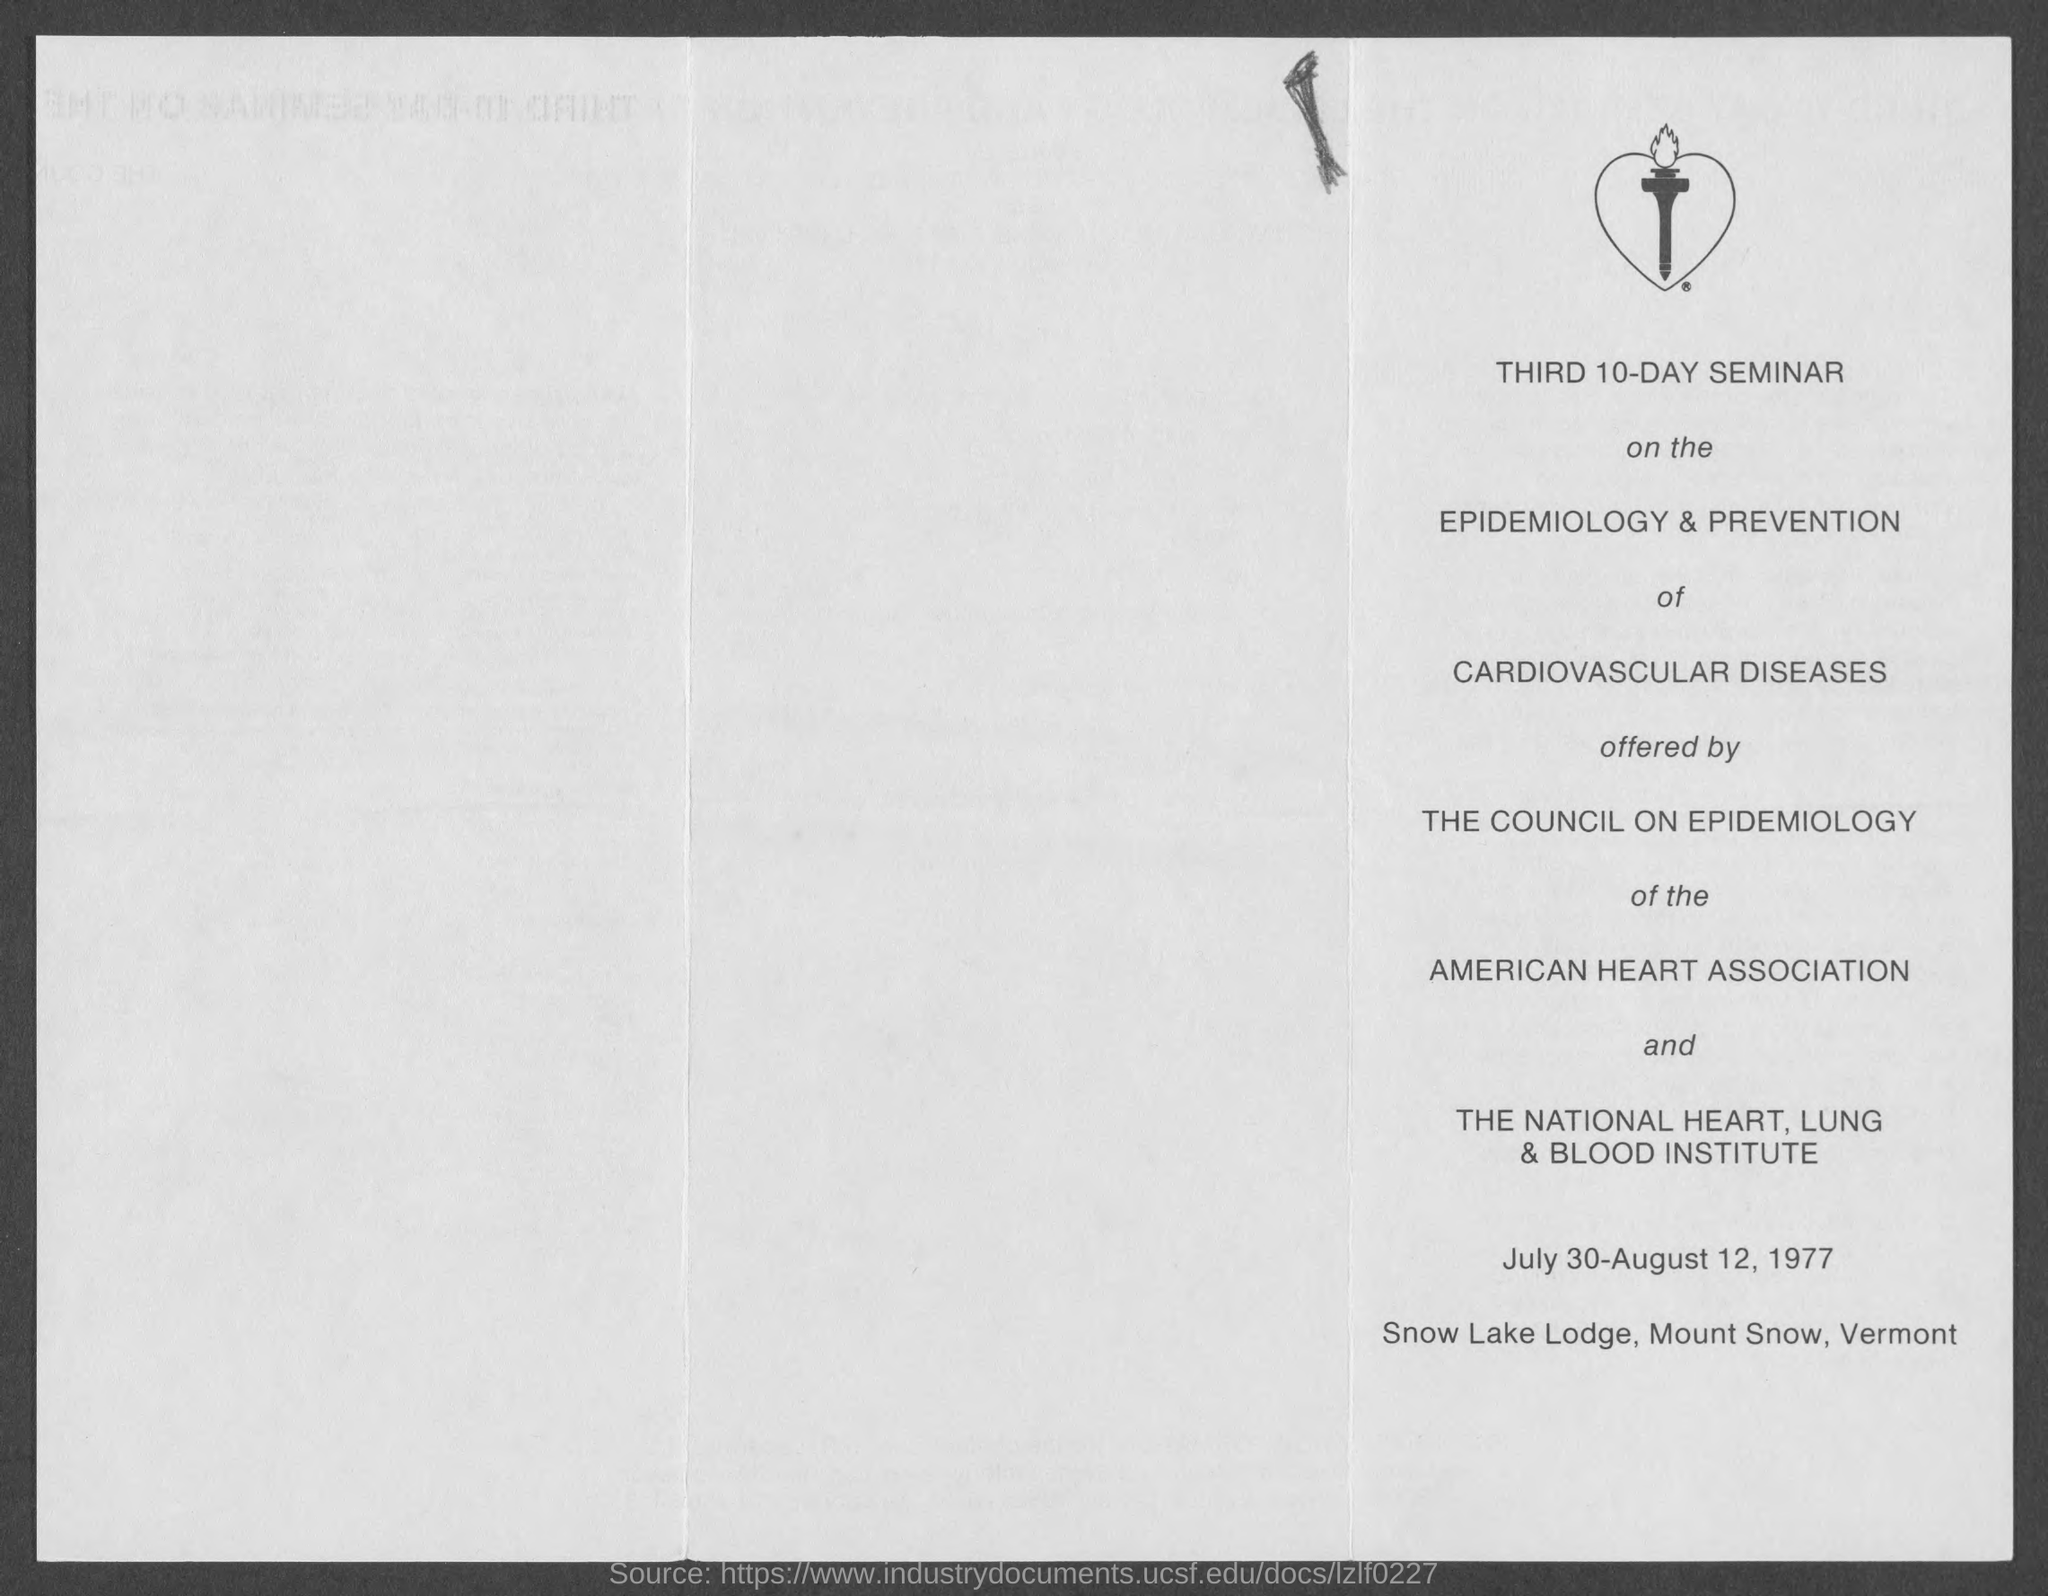Identify some key points in this picture. Cardiovascular diseases are the type of illness that was the focus of the seminar. The seminar will take place at Snow Lake Lodge, located in Mount Snow, Vermont. The Council on Epidemiology offered the seminar. The National Heart, Lung & Blood Institute has the power over The Council on Epidemiology. The American Heart Association has the power over The Council on Epidemiology. 